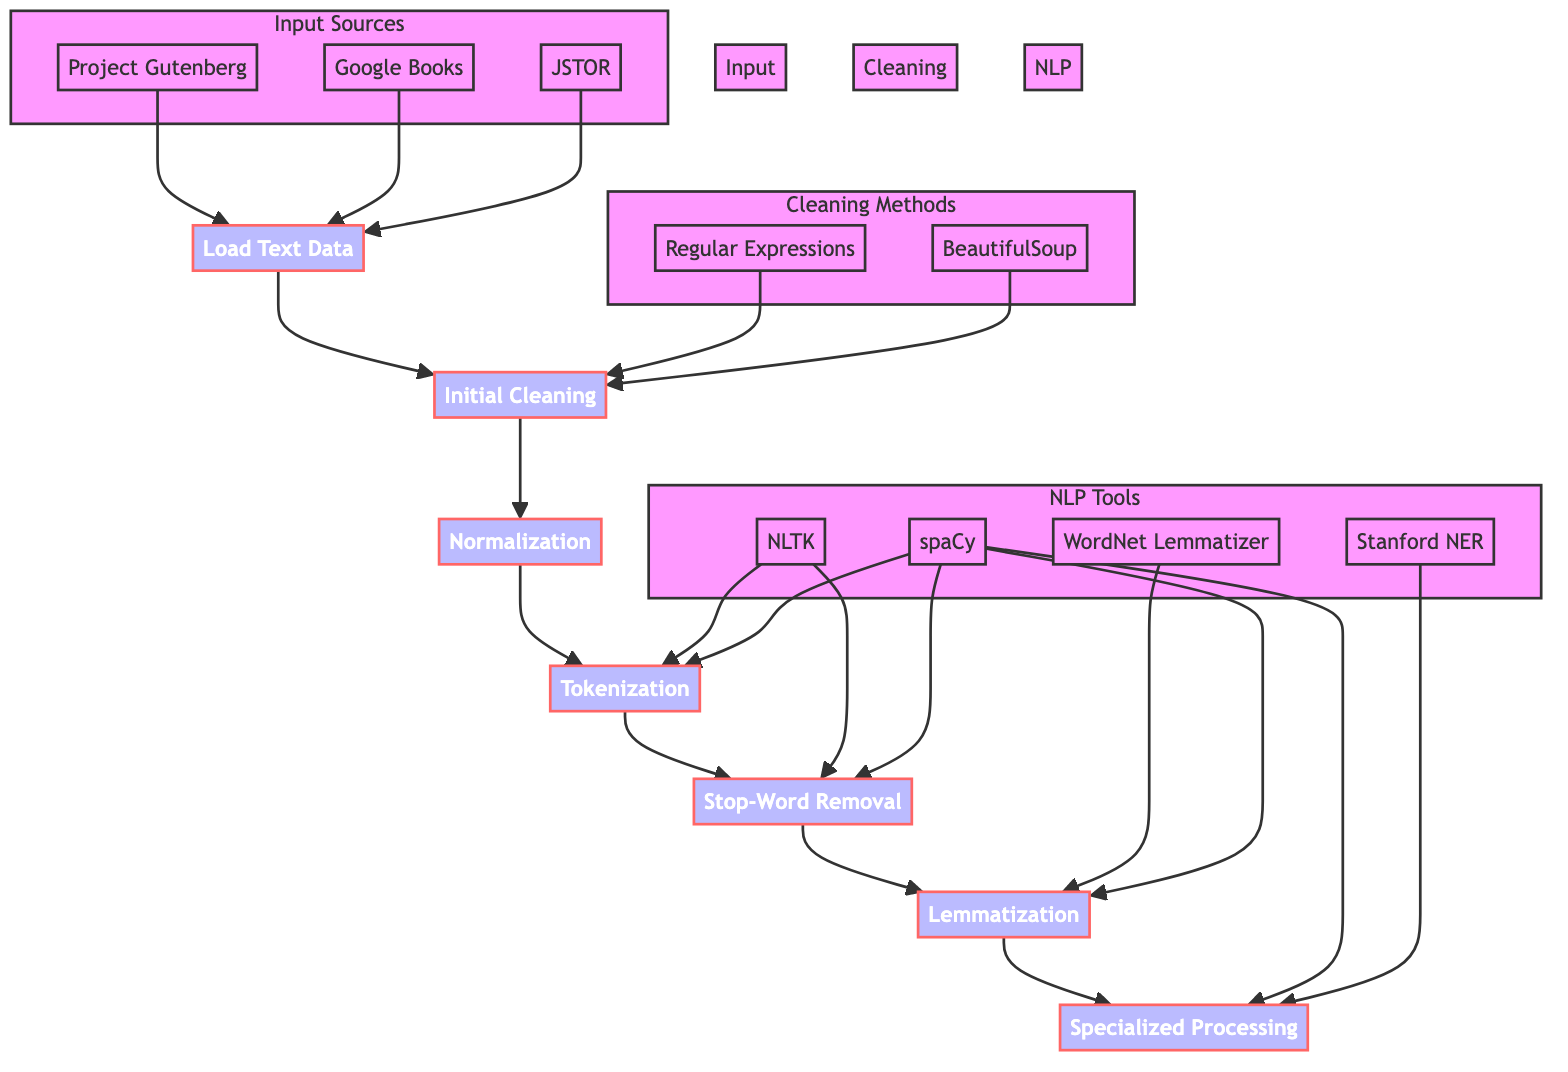What is the first step in the process? The diagram indicates that the first step is "Load Text Data," which starts the entire preprocessing process.
Answer: Load Text Data How many main steps are in the flow chart? The diagram outlines seven main steps in the preprocessing process, starting from loading data to specialized processing.
Answer: Seven Which tools are used for Tokenization? According to the diagram, both NLTK and spaCy are the tools mentioned for the tokenization step.
Answer: NLTK, spaCy What follows After Normalization? The flow chart shows that after the Normalization step, the next step is Tokenization.
Answer: Tokenization What are two methods used for Initial Cleaning? The diagram lists Regular Expressions and BeautifulSoup as the two methods used for the initial cleaning of text data.
Answer: Regular Expressions, BeautifulSoup Which step involves removing commonly used words? The Stop-Word Removal step is explicitly stated to focus on removing commonly used words that do not carry significant meaning.
Answer: Stop-Word Removal Which step applies domain-specific transformations? The diagram illustrates that Specialized Processing is the step dedicated to applying domain-specific transformations, such as named entity recognition.
Answer: Specialized Processing How are Stop-Word Removal and Lemmatization linked in the flow? The flow chart indicates that after Stop-Word Removal, the next step sequentially is Lemmatization, establishing a direct relationship between these two steps.
Answer: Sequential link What is the last step in the preprocessing process? According to the diagram, the last step in the preprocessing flow is Specialized Processing, which involves advanced techniques related to the domain of literary analysis.
Answer: Specialized Processing 